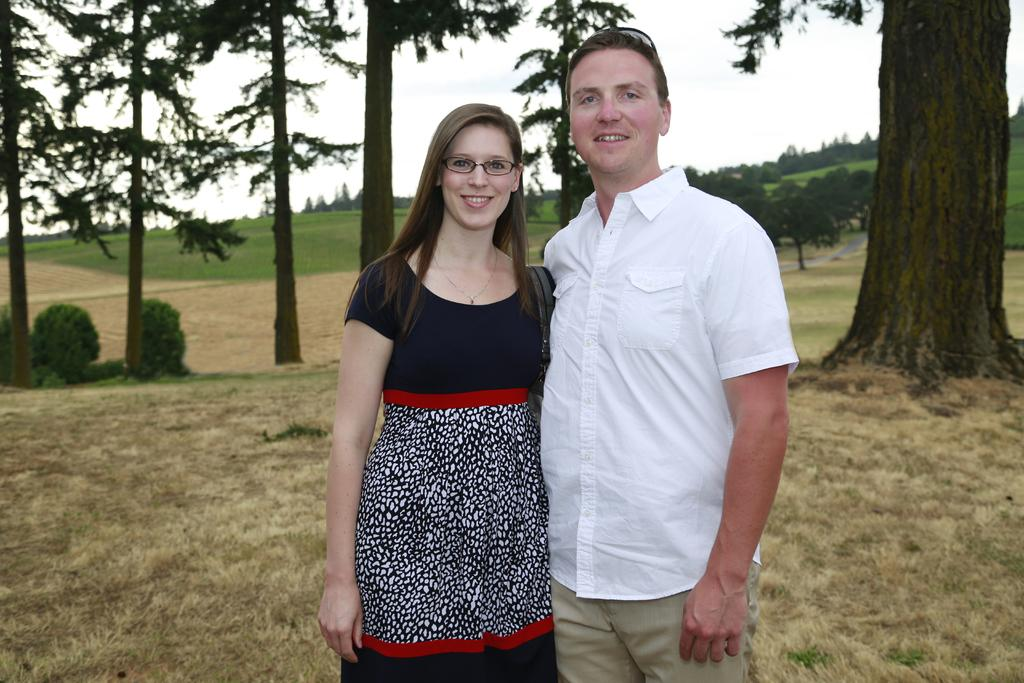How many people are present in the image? There are two people standing in the image. What is the condition of the ground in the image? The ground is covered with dry grass. Can you describe the woman's appearance in the image? The woman is wearing spectacles. What can be seen in the background of the image? There are trees visible in the background of the image. What type of glove is the man wearing in the image? There is no glove visible on either person in the image. How many bags can be seen in the image? There are no bags present in the image. 